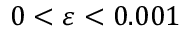Convert formula to latex. <formula><loc_0><loc_0><loc_500><loc_500>0 < \varepsilon < 0 . 0 0 1</formula> 